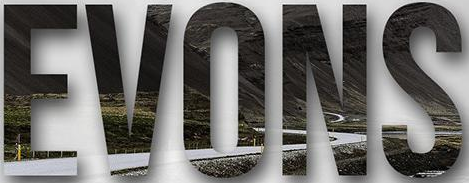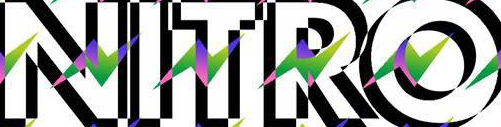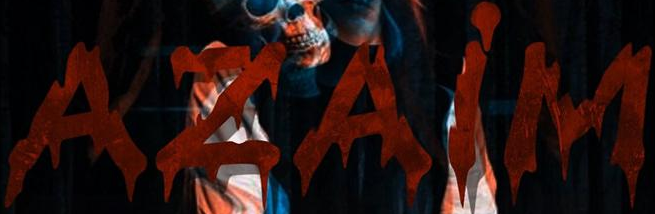What text is displayed in these images sequentially, separated by a semicolon? EVONS; NITRO; AZAiM 